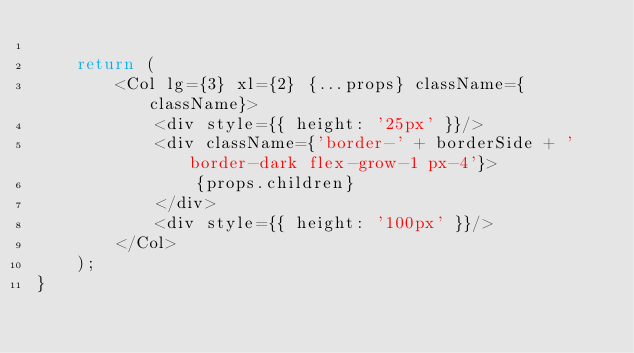<code> <loc_0><loc_0><loc_500><loc_500><_TypeScript_>
    return (
        <Col lg={3} xl={2} {...props} className={className}>
            <div style={{ height: '25px' }}/>
            <div className={'border-' + borderSide + ' border-dark flex-grow-1 px-4'}>
                {props.children}
            </div>
            <div style={{ height: '100px' }}/>
        </Col>
    );
}
</code> 